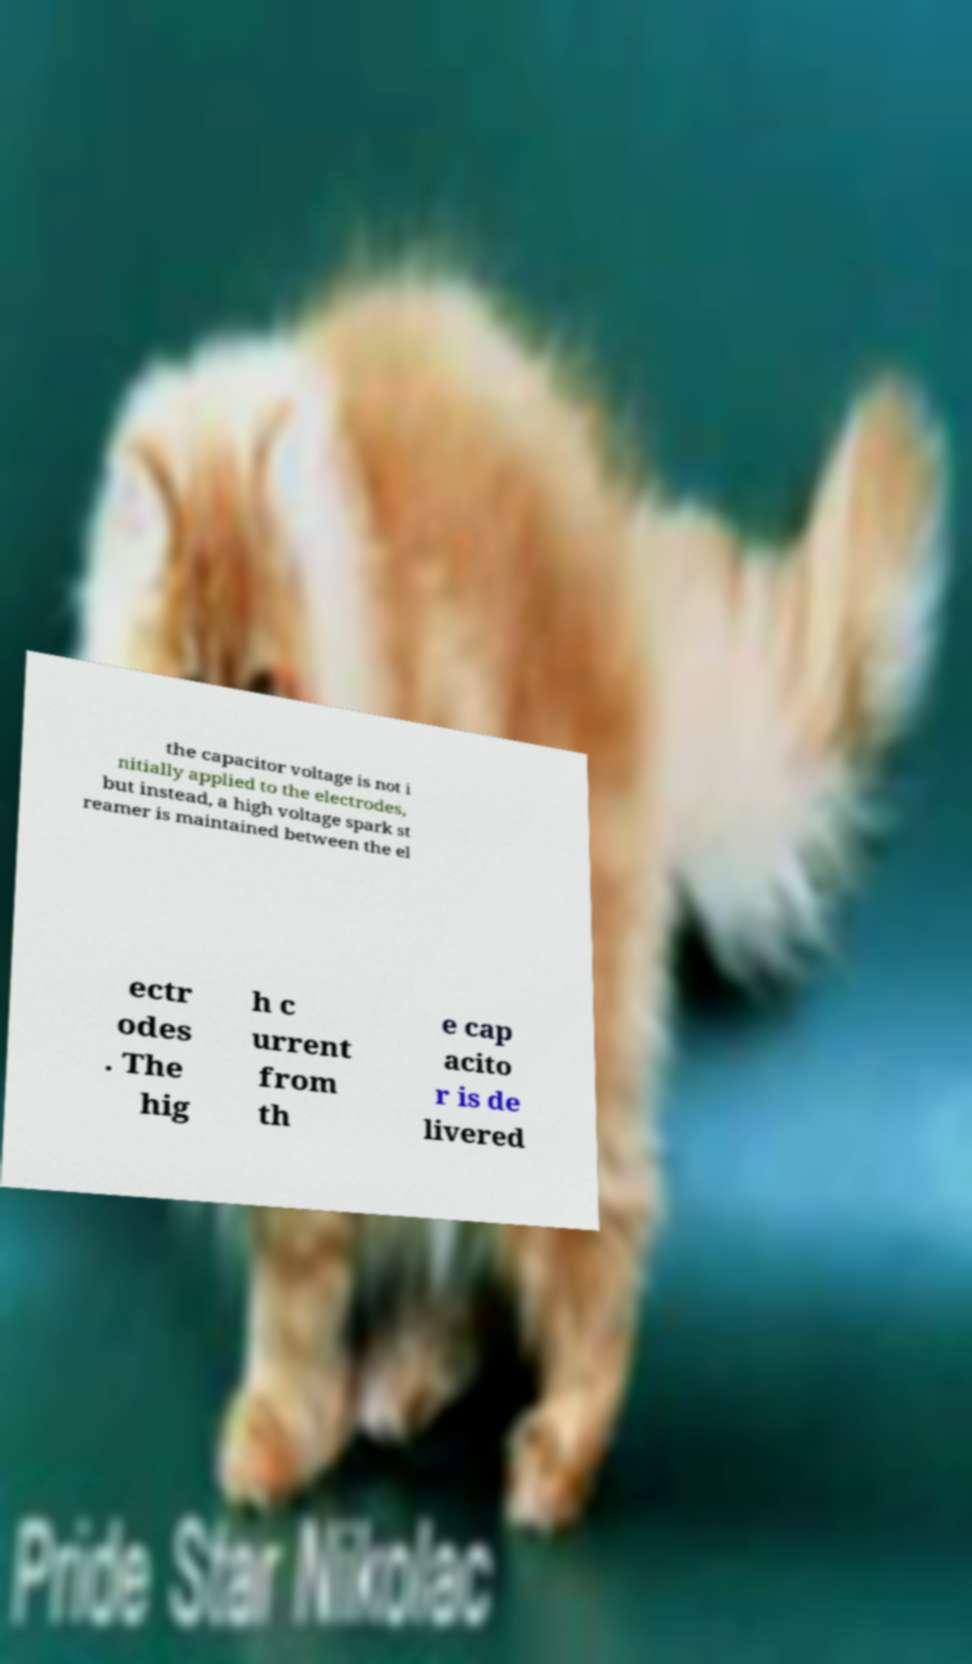What messages or text are displayed in this image? I need them in a readable, typed format. the capacitor voltage is not i nitially applied to the electrodes, but instead, a high voltage spark st reamer is maintained between the el ectr odes . The hig h c urrent from th e cap acito r is de livered 